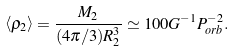<formula> <loc_0><loc_0><loc_500><loc_500>\left < \rho _ { 2 } \right > = \frac { M _ { 2 } } { ( 4 \pi / 3 ) R ^ { 3 } _ { 2 } } \simeq 1 0 0 G ^ { - 1 } P _ { o r b } ^ { - 2 } .</formula> 